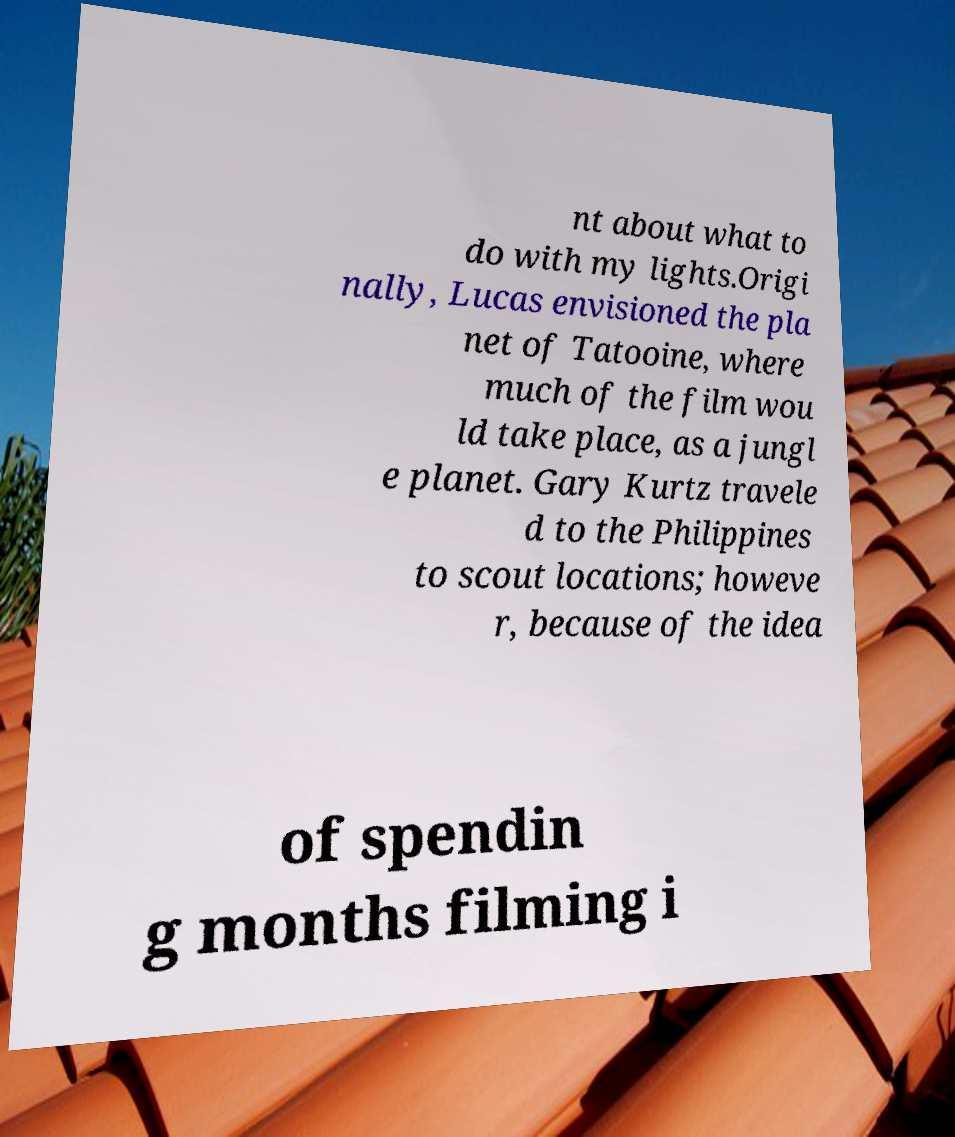Please read and relay the text visible in this image. What does it say? nt about what to do with my lights.Origi nally, Lucas envisioned the pla net of Tatooine, where much of the film wou ld take place, as a jungl e planet. Gary Kurtz travele d to the Philippines to scout locations; howeve r, because of the idea of spendin g months filming i 